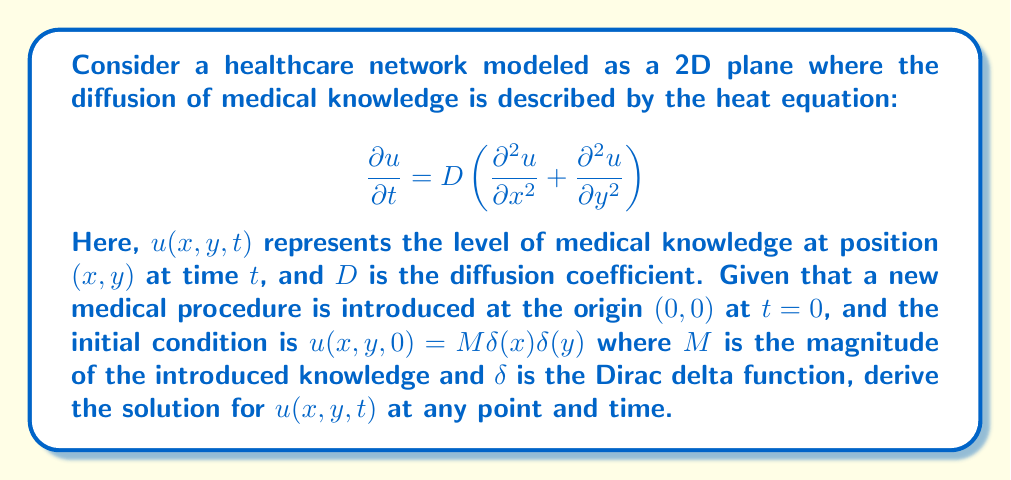Give your solution to this math problem. To solve this problem, we'll follow these steps:

1) The heat equation in 2D with the given initial condition is a well-known problem with a standard solution. The solution is given by the Green's function for the 2D heat equation:

   $$u(x,y,t) = \frac{M}{4\pi Dt} e^{-\frac{x^2+y^2}{4Dt}}$$

2) To verify this solution, we can check if it satisfies the heat equation and the initial condition:

   a) Checking the heat equation:
      $$\frac{\partial u}{\partial t} = \frac{M}{4\pi D} \left(-\frac{1}{t^2}e^{-\frac{x^2+y^2}{4Dt}} + \frac{x^2+y^2}{4Dt^3}e^{-\frac{x^2+y^2}{4Dt}}\right)$$
      
      $$\frac{\partial^2 u}{\partial x^2} = \frac{M}{4\pi Dt} \left(\frac{x^2}{4D^2t^2} - \frac{1}{2Dt}\right)e^{-\frac{x^2+y^2}{4Dt}}$$
      
      $$\frac{\partial^2 u}{\partial y^2} = \frac{M}{4\pi Dt} \left(\frac{y^2}{4D^2t^2} - \frac{1}{2Dt}\right)e^{-\frac{x^2+y^2}{4Dt}}$$

      Summing $\frac{\partial^2 u}{\partial x^2}$ and $\frac{\partial^2 u}{\partial y^2}$ and multiplying by $D$, we get $\frac{\partial u}{\partial t}$, confirming that the solution satisfies the heat equation.

   b) Checking the initial condition:
      As $t \to 0$, $u(x,y,t)$ approaches $M\delta(x)\delta(y)$, satisfying the initial condition.

3) Interpretation for healthcare economics:
   - The solution shows how medical knowledge spreads over time and space in the healthcare network.
   - At any given time $t$, the knowledge distribution is a 2D Gaussian centered at the origin.
   - The spread of knowledge is characterized by the standard deviation $\sigma = \sqrt{2Dt}$, which increases with time and diffusion coefficient.
   - The peak knowledge level at the origin decreases over time as $\frac{M}{4\pi Dt}$, reflecting the spread of knowledge to surrounding areas.

This solution can help healthcare economists analyze how quickly new medical procedures or information diffuse through healthcare networks, which can impact economic decisions related to training, resource allocation, and technology adoption.
Answer: $u(x,y,t) = \frac{M}{4\pi Dt} e^{-\frac{x^2+y^2}{4Dt}}$ 